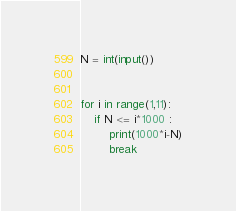Convert code to text. <code><loc_0><loc_0><loc_500><loc_500><_Python_>N = int(input())


for i in range(1,11):
    if N <= i*1000 :
        print(1000*i-N)
        break
</code> 